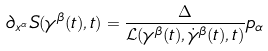<formula> <loc_0><loc_0><loc_500><loc_500>\partial _ { x ^ { \alpha } } S ( \gamma ^ { \beta } ( t ) , t ) = \frac { \Delta } { \mathcal { L } ( \gamma ^ { \beta } ( t ) , \dot { \gamma } ^ { \beta } ( t ) , t ) } p _ { \alpha }</formula> 